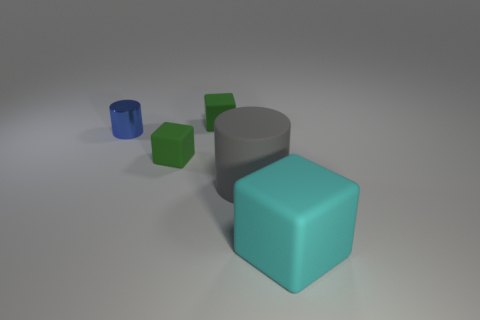Is there any other thing that is the same material as the small cylinder?
Provide a succinct answer. No. What is the big object on the left side of the block that is in front of the large gray matte object made of?
Provide a succinct answer. Rubber. How big is the rubber cylinder?
Offer a terse response. Large. There is a green thing that is in front of the blue thing; is it the same size as the large block?
Your response must be concise. No. What shape is the tiny matte object to the left of the tiny object to the right of the small matte block that is in front of the blue metal cylinder?
Ensure brevity in your answer.  Cube. How many objects are purple rubber cylinders or green rubber things behind the blue shiny cylinder?
Offer a very short reply. 1. What size is the green matte thing in front of the tiny shiny cylinder?
Your answer should be very brief. Small. Is the material of the cyan thing the same as the green cube behind the small metallic thing?
Your response must be concise. Yes. How many tiny blue metal cylinders are in front of the cyan rubber thing right of the big object on the left side of the large cyan matte thing?
Provide a short and direct response. 0. What number of gray things are either cylinders or large things?
Ensure brevity in your answer.  1. 